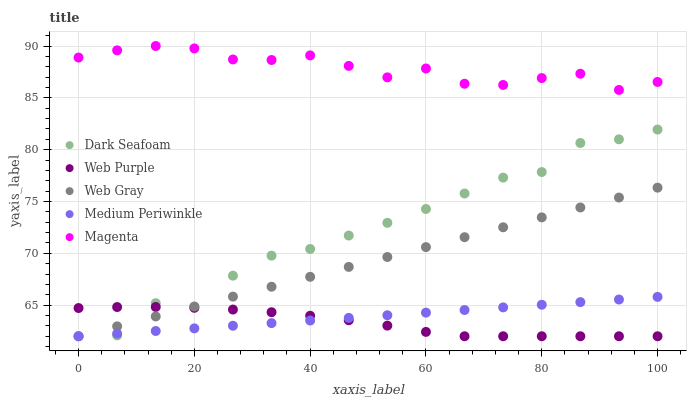Does Web Purple have the minimum area under the curve?
Answer yes or no. Yes. Does Magenta have the maximum area under the curve?
Answer yes or no. Yes. Does Web Gray have the minimum area under the curve?
Answer yes or no. No. Does Web Gray have the maximum area under the curve?
Answer yes or no. No. Is Web Gray the smoothest?
Answer yes or no. Yes. Is Dark Seafoam the roughest?
Answer yes or no. Yes. Is Medium Periwinkle the smoothest?
Answer yes or no. No. Is Medium Periwinkle the roughest?
Answer yes or no. No. Does Dark Seafoam have the lowest value?
Answer yes or no. Yes. Does Magenta have the lowest value?
Answer yes or no. No. Does Magenta have the highest value?
Answer yes or no. Yes. Does Web Gray have the highest value?
Answer yes or no. No. Is Web Gray less than Magenta?
Answer yes or no. Yes. Is Magenta greater than Dark Seafoam?
Answer yes or no. Yes. Does Medium Periwinkle intersect Dark Seafoam?
Answer yes or no. Yes. Is Medium Periwinkle less than Dark Seafoam?
Answer yes or no. No. Is Medium Periwinkle greater than Dark Seafoam?
Answer yes or no. No. Does Web Gray intersect Magenta?
Answer yes or no. No. 